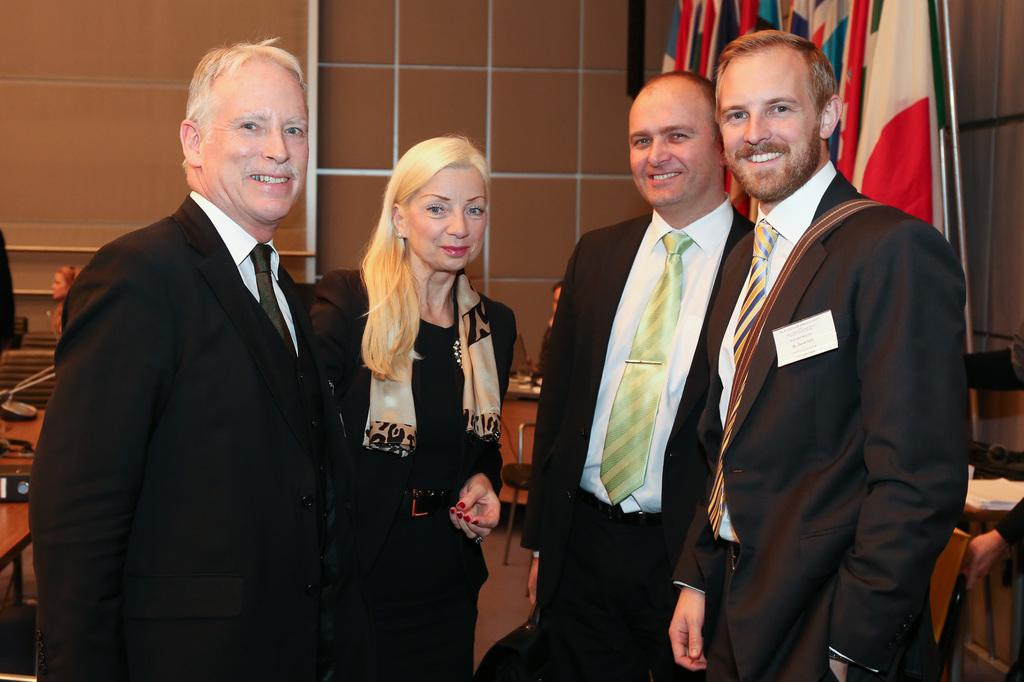How many people are in the image? There are three men and a woman standing in the image, making a total of four people. What are the individuals wearing? The individuals are wearing clothes. What can be seen in the image besides the people? There is a flag, a chair, a floor, a table, and a wall in the image. What type of trail can be seen in the image? There is no trail present in the image. Is there a boat visible in the image? No, there is no boat present in the image. 